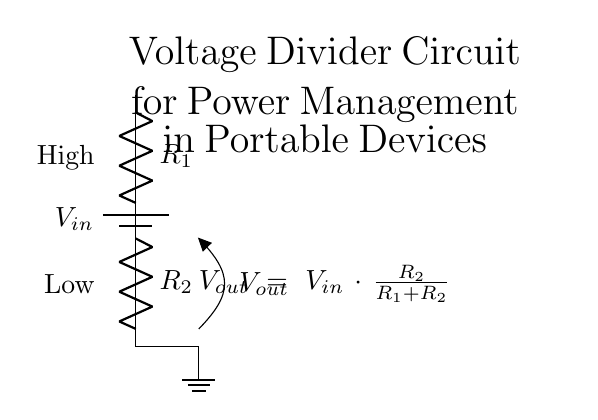What is the input voltage in this circuit? The input voltage is denoted by V sub in, and it is represented at the top of the circuit schematic as the source.
Answer: V in What are the two resistors used in the voltage divider? The circuit contains two resistors labeled R sub 1 and R sub 2, which are shown in series with connections to the power source at the top and ground at the bottom.
Answer: R 1 and R 2 What is the formula for the output voltage? The output voltage is stated in the circuit diagram as V out equals V in multiplied by the ratio of R 2 to the sum of R 1 and R 2, which indicates how the output voltage is derived from the input based on resistance values.
Answer: V out = V in * R 2 / (R 1 + R 2) What does the output voltage depend on? The output voltage depends on two factors: the input voltage and the resistance values of R 1 and R 2, since the formula shows how these variables interact to determine V out.
Answer: V in and R 1, R 2 Which side of the circuit is considered high voltage? The side of the circuit where R 1 connects to the voltage source is labeled as high, indicating it has a higher potential compared to the lower side connected to ground.
Answer: High How does changing R 1 affect V out? Increasing R 1 would increase the total resistance in the denominator of the output voltage formula which would decrease V out, while decreasing R 1 would do the opposite, showing how the voltage output is impacted by changes in resistance.
Answer: V out decreases What is the role of the voltage divider in portable devices? The voltage divider's role in portable devices is to reduce the voltage supply to a lower level, which is necessary for powering specific electronic components that require less voltage than the input source.
Answer: Voltage regulation 